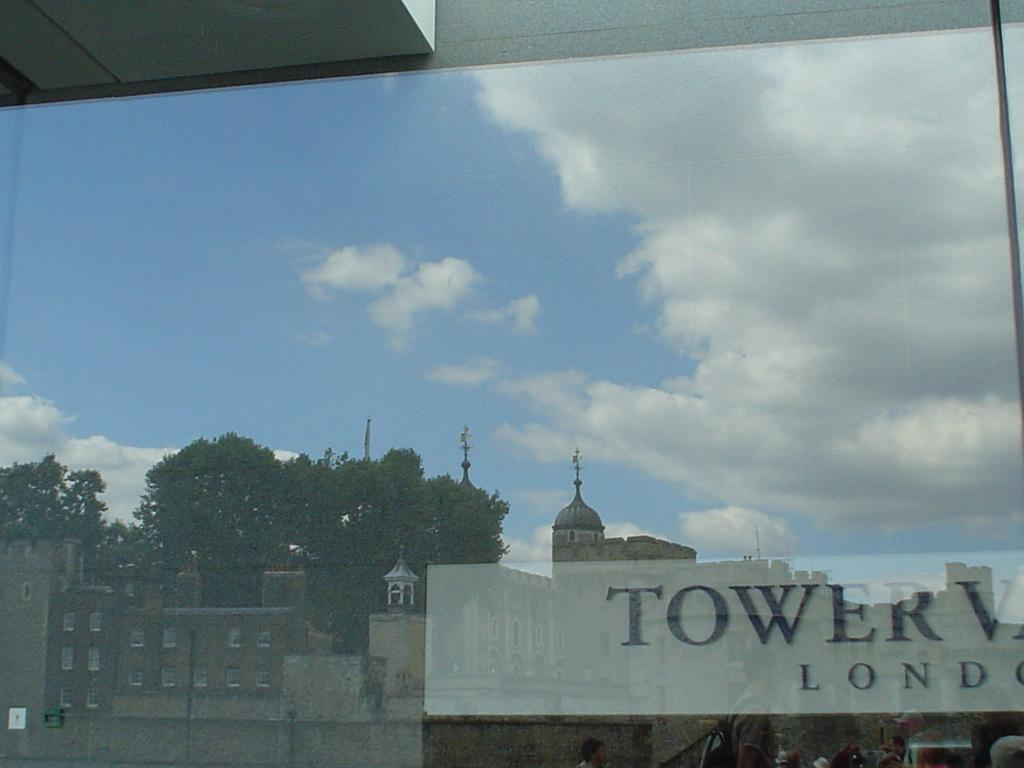Provide a one-sentence caption for the provided image. The building across the way has the word "tower" written on it. 